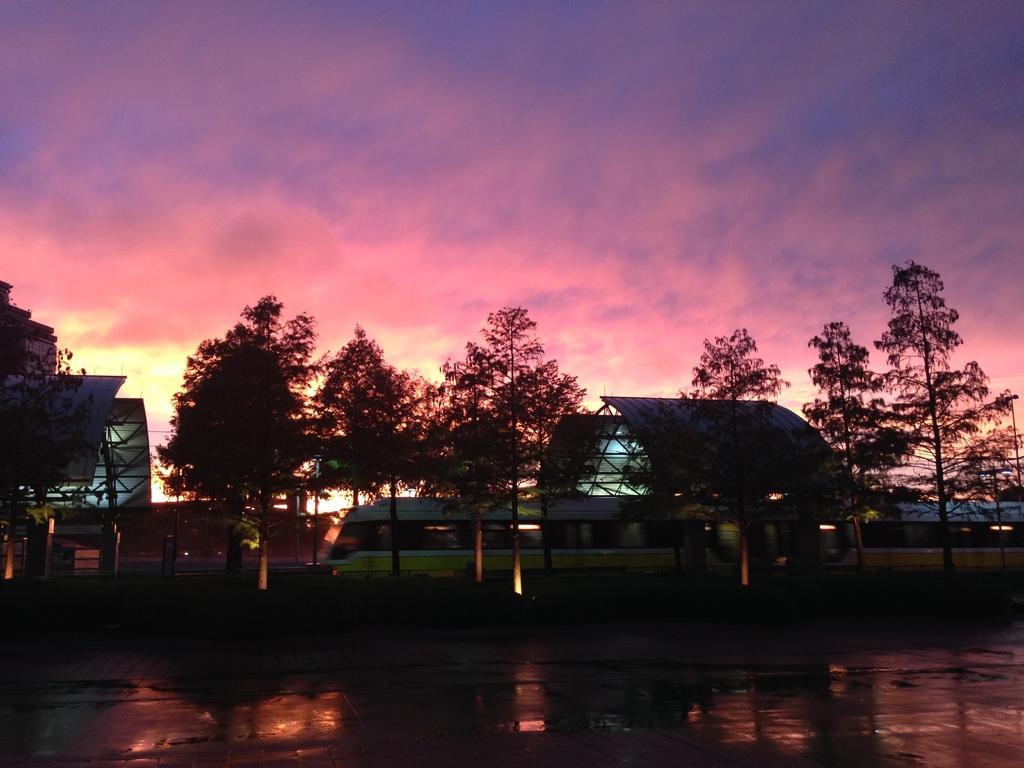Could you give a brief overview of what you see in this image? In the center of the image we can see the sky, clouds, trees, one train and a few other objects. 